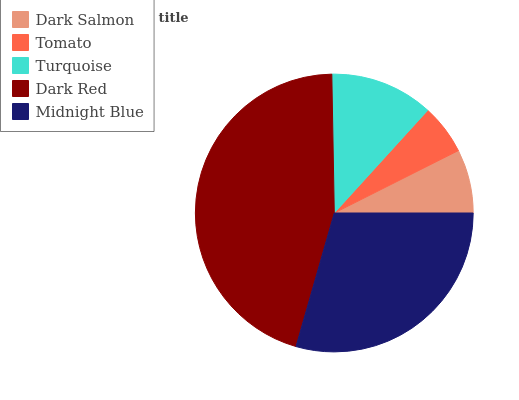Is Tomato the minimum?
Answer yes or no. Yes. Is Dark Red the maximum?
Answer yes or no. Yes. Is Turquoise the minimum?
Answer yes or no. No. Is Turquoise the maximum?
Answer yes or no. No. Is Turquoise greater than Tomato?
Answer yes or no. Yes. Is Tomato less than Turquoise?
Answer yes or no. Yes. Is Tomato greater than Turquoise?
Answer yes or no. No. Is Turquoise less than Tomato?
Answer yes or no. No. Is Turquoise the high median?
Answer yes or no. Yes. Is Turquoise the low median?
Answer yes or no. Yes. Is Dark Salmon the high median?
Answer yes or no. No. Is Midnight Blue the low median?
Answer yes or no. No. 